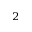<formula> <loc_0><loc_0><loc_500><loc_500>_ { 2 }</formula> 